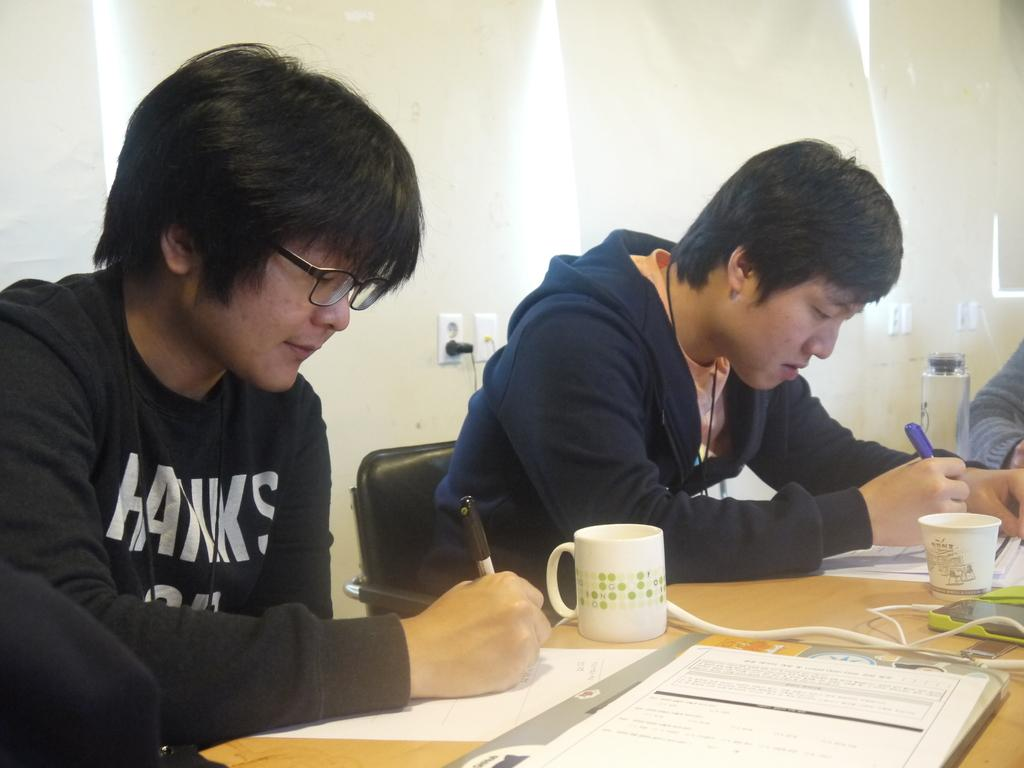What are the men in the image doing? The men are sitting on chairs in the image. What can be seen on the table in the image? There is a glass, paper, and a cable on the table in the image. What is the background of the image? There is a wall in the image. What type of stem can be seen growing from the shoes in the image? There are no shoes or stems present in the image. 